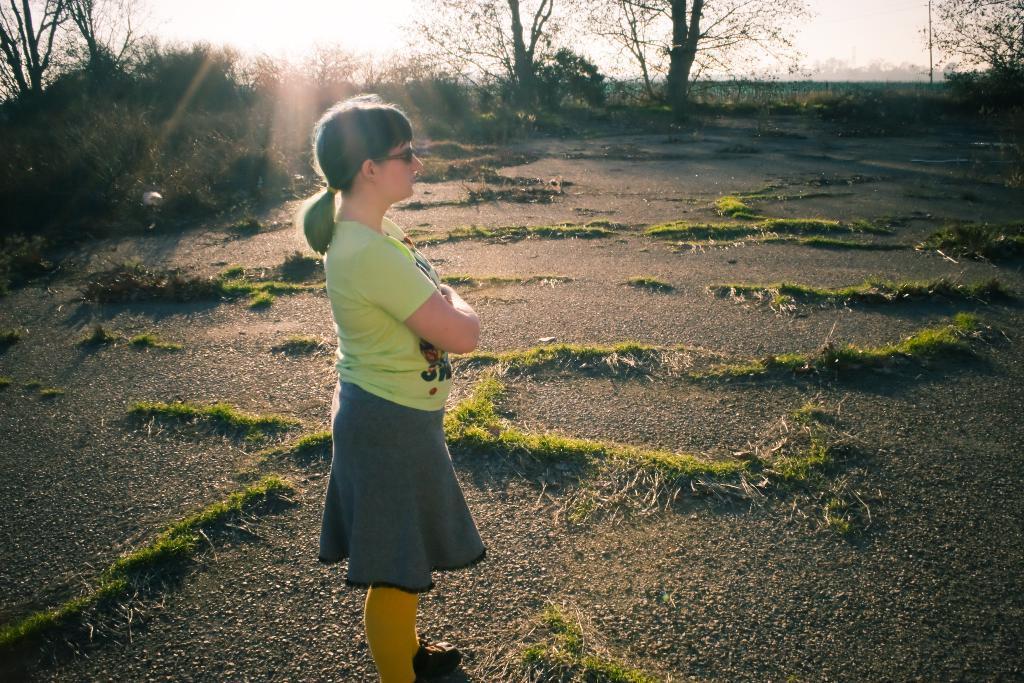Please provide a concise description of this image. In this image, we can see a person. We can see the ground. We can see some grass, plants and trees. In the background, we can see some objects. We can also see the sky. 